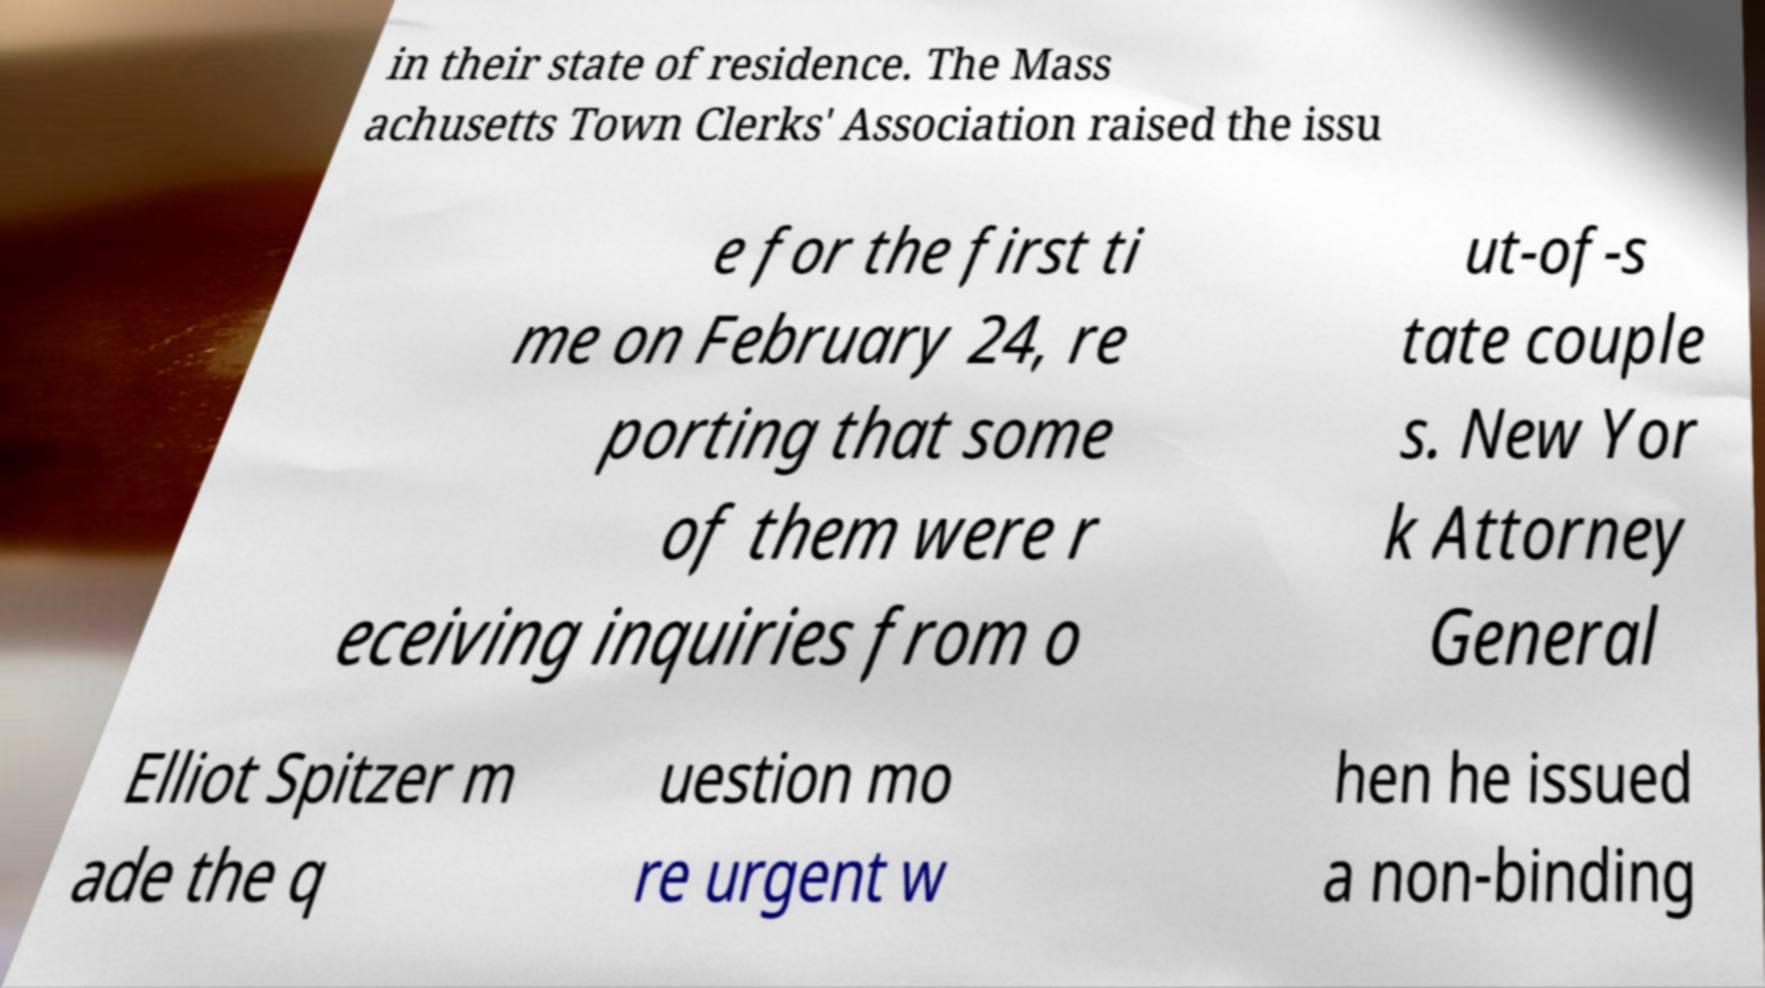Please identify and transcribe the text found in this image. in their state of residence. The Mass achusetts Town Clerks' Association raised the issu e for the first ti me on February 24, re porting that some of them were r eceiving inquiries from o ut-of-s tate couple s. New Yor k Attorney General Elliot Spitzer m ade the q uestion mo re urgent w hen he issued a non-binding 